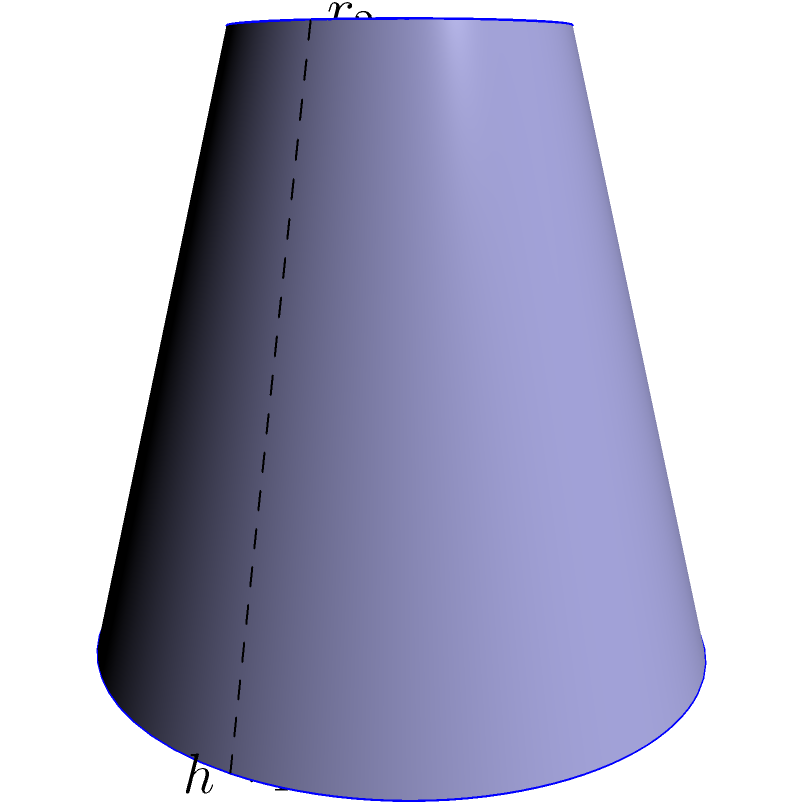As a mobile app developer, you're creating a 3D modeling feature for an educational app. You need to implement a function to calculate the volume of a frustum (a truncated cone). Given the top radius $r_2 = 5$ cm, bottom radius $r_1 = 8$ cm, and height $h = 12$ cm, what is the volume of the frustum in cubic centimeters? Round your answer to the nearest whole number. To calculate the volume of a frustum, we can use the following formula:

$$V = \frac{1}{3}\pi h(r_1^2 + r_2^2 + r_1r_2)$$

Where:
$V$ = volume
$h$ = height
$r_1$ = radius of the base (bottom)
$r_2$ = radius of the top

Let's plug in our values:

$h = 12$ cm
$r_1 = 8$ cm
$r_2 = 5$ cm

Now, let's calculate step by step:

1) First, calculate $r_1^2$, $r_2^2$, and $r_1r_2$:
   $r_1^2 = 8^2 = 64$
   $r_2^2 = 5^2 = 25$
   $r_1r_2 = 8 * 5 = 40$

2) Add these values:
   $r_1^2 + r_2^2 + r_1r_2 = 64 + 25 + 40 = 129$

3) Multiply by $h$:
   $h(r_1^2 + r_2^2 + r_1r_2) = 12 * 129 = 1548$

4) Multiply by $\frac{1}{3}\pi$:
   $V = \frac{1}{3}\pi * 1548 \approx 1621.95$ cm³

5) Rounding to the nearest whole number:
   $V \approx 1622$ cm³
Answer: 1622 cm³ 